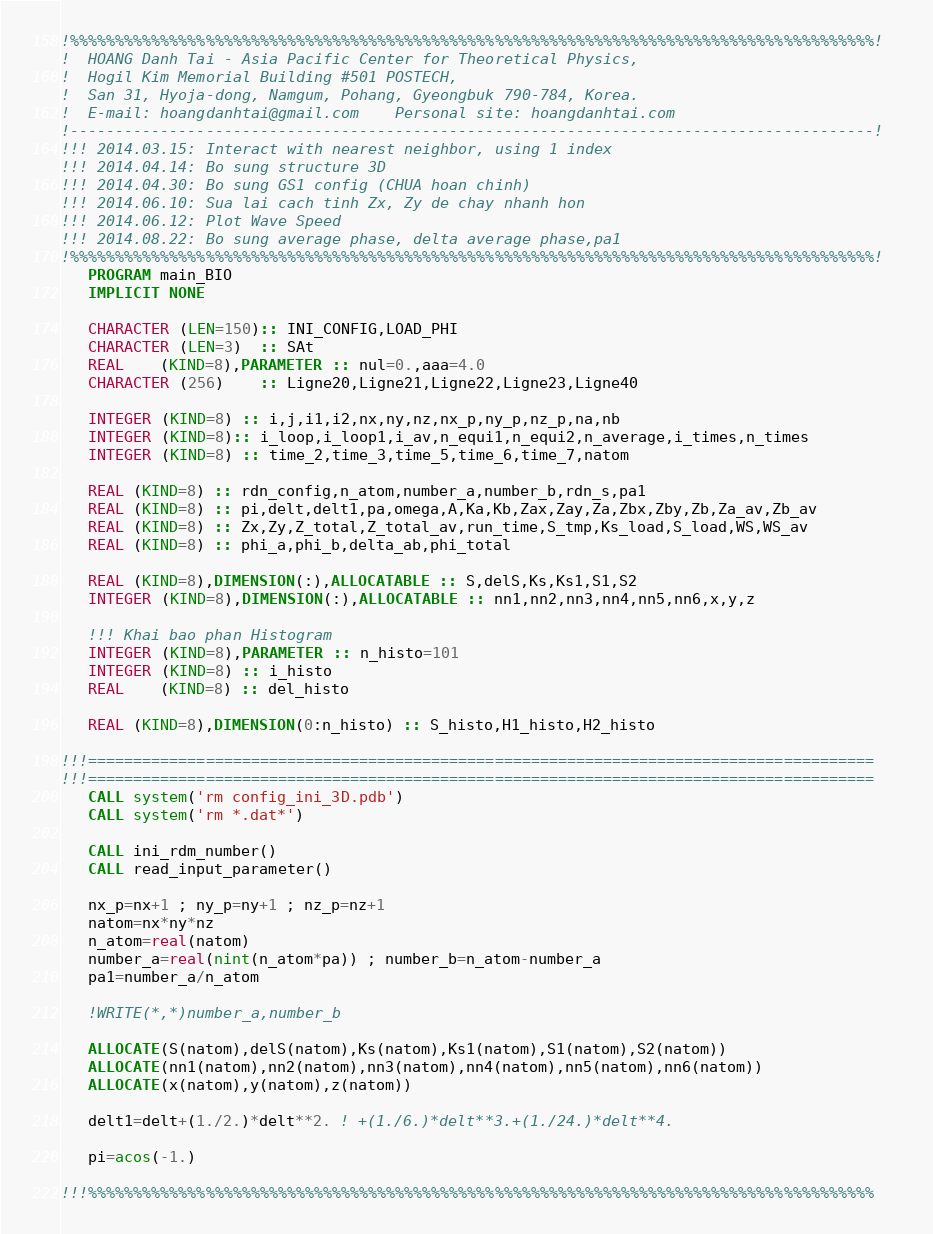Convert code to text. <code><loc_0><loc_0><loc_500><loc_500><_FORTRAN_>!%%%%%%%%%%%%%%%%%%%%%%%%%%%%%%%%%%%%%%%%%%%%%%%%%%%%%%%%%%%%%%%%%%%%%%%%%%%%%%%%%%%%%%%%%!
!  HOANG Danh Tai - Asia Pacific Center for Theoretical Physics, 
!  Hogil Kim Memorial Building #501 POSTECH,
!  San 31, Hyoja-dong, Namgum, Pohang, Gyeongbuk 790-784, Korea.
!  E-mail: hoangdanhtai@gmail.com    Personal site: hoangdanhtai.com 
!-----------------------------------------------------------------------------------------!
!!! 2014.03.15: Interact with nearest neighbor, using 1 index
!!! 2014.04.14: Bo sung structure 3D
!!! 2014.04.30: Bo sung GS1 config (CHUA hoan chinh)
!!! 2014.06.10: Sua lai cach tinh Zx, Zy de chay nhanh hon
!!! 2014.06.12: Plot Wave Speed
!!! 2014.08.22: Bo sung average phase, delta average phase,pa1
!%%%%%%%%%%%%%%%%%%%%%%%%%%%%%%%%%%%%%%%%%%%%%%%%%%%%%%%%%%%%%%%%%%%%%%%%%%%%%%%%%%%%%%%%%! 
   PROGRAM main_BIO
   IMPLICIT NONE

   CHARACTER (LEN=150):: INI_CONFIG,LOAD_PHI
   CHARACTER (LEN=3)  :: SAt
   REAL    (KIND=8),PARAMETER :: nul=0.,aaa=4.0
   CHARACTER (256)    :: Ligne20,Ligne21,Ligne22,Ligne23,Ligne40

   INTEGER (KIND=8) :: i,j,i1,i2,nx,ny,nz,nx_p,ny_p,nz_p,na,nb
   INTEGER (KIND=8):: i_loop,i_loop1,i_av,n_equi1,n_equi2,n_average,i_times,n_times
   INTEGER (KIND=8) :: time_2,time_3,time_5,time_6,time_7,natom
   
   REAL (KIND=8) :: rdn_config,n_atom,number_a,number_b,rdn_s,pa1
   REAL (KIND=8) :: pi,delt,delt1,pa,omega,A,Ka,Kb,Zax,Zay,Za,Zbx,Zby,Zb,Za_av,Zb_av
   REAL (KIND=8) :: Zx,Zy,Z_total,Z_total_av,run_time,S_tmp,Ks_load,S_load,WS,WS_av
   REAL (KIND=8) :: phi_a,phi_b,delta_ab,phi_total

   REAL (KIND=8),DIMENSION(:),ALLOCATABLE :: S,delS,Ks,Ks1,S1,S2
   INTEGER (KIND=8),DIMENSION(:),ALLOCATABLE :: nn1,nn2,nn3,nn4,nn5,nn6,x,y,z

   !!! Khai bao phan Histogram
   INTEGER (KIND=8),PARAMETER :: n_histo=101
   INTEGER (KIND=8) :: i_histo
   REAL    (KIND=8) :: del_histo

   REAL (KIND=8),DIMENSION(0:n_histo) :: S_histo,H1_histo,H2_histo
      
!!!=======================================================================================   
!!!=======================================================================================
   CALL system('rm config_ini_3D.pdb')
   CALL system('rm *.dat*')

   CALL ini_rdm_number()
   CALL read_input_parameter()

   nx_p=nx+1 ; ny_p=ny+1 ; nz_p=nz+1
   natom=nx*ny*nz
   n_atom=real(natom)
   number_a=real(nint(n_atom*pa)) ; number_b=n_atom-number_a
   pa1=number_a/n_atom

   !WRITE(*,*)number_a,number_b

   ALLOCATE(S(natom),delS(natom),Ks(natom),Ks1(natom),S1(natom),S2(natom))
   ALLOCATE(nn1(natom),nn2(natom),nn3(natom),nn4(natom),nn5(natom),nn6(natom))
   ALLOCATE(x(natom),y(natom),z(natom))

   delt1=delt+(1./2.)*delt**2. ! +(1./6.)*delt**3.+(1./24.)*delt**4.
   
   pi=acos(-1.)

!!!%%%%%%%%%%%%%%%%%%%%%%%%%%%%%%%%%%%%%%%%%%%%%%%%%%%%%%%%%%%%%%%%%%%%%%%%%%%%%%%%%%%%%%%</code> 